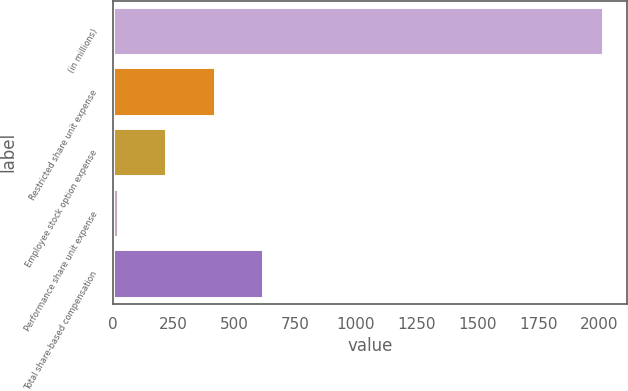<chart> <loc_0><loc_0><loc_500><loc_500><bar_chart><fcel>(in millions)<fcel>Restricted share unit expense<fcel>Employee stock option expense<fcel>Performance share unit expense<fcel>Total share-based compensation<nl><fcel>2015<fcel>419<fcel>219.5<fcel>20<fcel>618.5<nl></chart> 